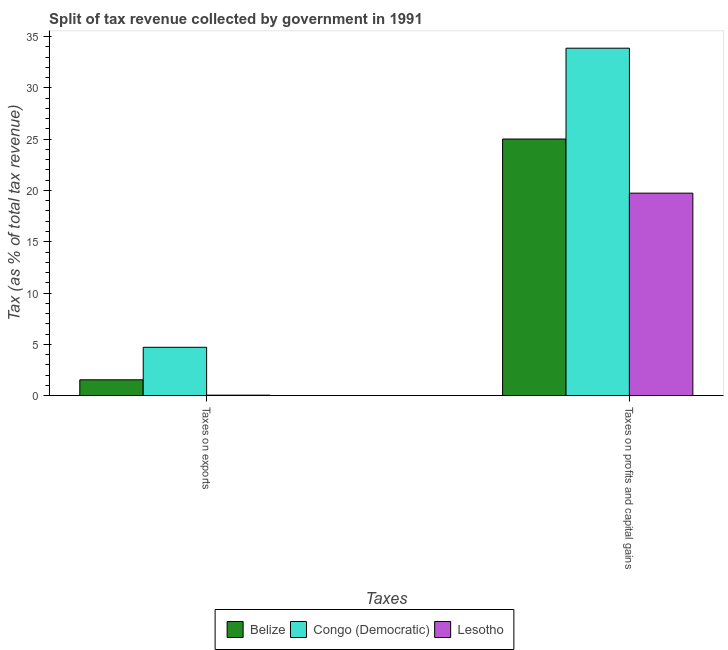How many different coloured bars are there?
Ensure brevity in your answer.  3. How many bars are there on the 1st tick from the left?
Your response must be concise. 3. What is the label of the 2nd group of bars from the left?
Your response must be concise. Taxes on profits and capital gains. What is the percentage of revenue obtained from taxes on profits and capital gains in Congo (Democratic)?
Provide a short and direct response. 33.86. Across all countries, what is the maximum percentage of revenue obtained from taxes on profits and capital gains?
Ensure brevity in your answer.  33.86. Across all countries, what is the minimum percentage of revenue obtained from taxes on profits and capital gains?
Your answer should be very brief. 19.74. In which country was the percentage of revenue obtained from taxes on profits and capital gains maximum?
Offer a terse response. Congo (Democratic). In which country was the percentage of revenue obtained from taxes on profits and capital gains minimum?
Make the answer very short. Lesotho. What is the total percentage of revenue obtained from taxes on profits and capital gains in the graph?
Your answer should be compact. 78.61. What is the difference between the percentage of revenue obtained from taxes on profits and capital gains in Belize and that in Lesotho?
Make the answer very short. 5.28. What is the difference between the percentage of revenue obtained from taxes on profits and capital gains in Lesotho and the percentage of revenue obtained from taxes on exports in Congo (Democratic)?
Ensure brevity in your answer.  15.02. What is the average percentage of revenue obtained from taxes on exports per country?
Keep it short and to the point. 2.1. What is the difference between the percentage of revenue obtained from taxes on profits and capital gains and percentage of revenue obtained from taxes on exports in Lesotho?
Provide a short and direct response. 19.69. In how many countries, is the percentage of revenue obtained from taxes on profits and capital gains greater than 21 %?
Give a very brief answer. 2. What is the ratio of the percentage of revenue obtained from taxes on profits and capital gains in Congo (Democratic) to that in Lesotho?
Provide a succinct answer. 1.72. Is the percentage of revenue obtained from taxes on profits and capital gains in Congo (Democratic) less than that in Belize?
Offer a terse response. No. In how many countries, is the percentage of revenue obtained from taxes on profits and capital gains greater than the average percentage of revenue obtained from taxes on profits and capital gains taken over all countries?
Your response must be concise. 1. What does the 2nd bar from the left in Taxes on exports represents?
Provide a succinct answer. Congo (Democratic). What does the 2nd bar from the right in Taxes on profits and capital gains represents?
Offer a terse response. Congo (Democratic). Are all the bars in the graph horizontal?
Your answer should be compact. No. How many countries are there in the graph?
Provide a succinct answer. 3. What is the difference between two consecutive major ticks on the Y-axis?
Offer a very short reply. 5. What is the title of the graph?
Give a very brief answer. Split of tax revenue collected by government in 1991. Does "St. Kitts and Nevis" appear as one of the legend labels in the graph?
Keep it short and to the point. No. What is the label or title of the X-axis?
Provide a succinct answer. Taxes. What is the label or title of the Y-axis?
Your answer should be compact. Tax (as % of total tax revenue). What is the Tax (as % of total tax revenue) in Belize in Taxes on exports?
Give a very brief answer. 1.54. What is the Tax (as % of total tax revenue) of Congo (Democratic) in Taxes on exports?
Give a very brief answer. 4.71. What is the Tax (as % of total tax revenue) in Lesotho in Taxes on exports?
Provide a succinct answer. 0.05. What is the Tax (as % of total tax revenue) in Belize in Taxes on profits and capital gains?
Make the answer very short. 25.01. What is the Tax (as % of total tax revenue) in Congo (Democratic) in Taxes on profits and capital gains?
Make the answer very short. 33.86. What is the Tax (as % of total tax revenue) in Lesotho in Taxes on profits and capital gains?
Offer a very short reply. 19.74. Across all Taxes, what is the maximum Tax (as % of total tax revenue) in Belize?
Offer a terse response. 25.01. Across all Taxes, what is the maximum Tax (as % of total tax revenue) in Congo (Democratic)?
Offer a terse response. 33.86. Across all Taxes, what is the maximum Tax (as % of total tax revenue) of Lesotho?
Your answer should be very brief. 19.74. Across all Taxes, what is the minimum Tax (as % of total tax revenue) of Belize?
Keep it short and to the point. 1.54. Across all Taxes, what is the minimum Tax (as % of total tax revenue) in Congo (Democratic)?
Offer a terse response. 4.71. Across all Taxes, what is the minimum Tax (as % of total tax revenue) in Lesotho?
Your response must be concise. 0.05. What is the total Tax (as % of total tax revenue) of Belize in the graph?
Give a very brief answer. 26.56. What is the total Tax (as % of total tax revenue) in Congo (Democratic) in the graph?
Your response must be concise. 38.58. What is the total Tax (as % of total tax revenue) in Lesotho in the graph?
Make the answer very short. 19.78. What is the difference between the Tax (as % of total tax revenue) of Belize in Taxes on exports and that in Taxes on profits and capital gains?
Make the answer very short. -23.47. What is the difference between the Tax (as % of total tax revenue) in Congo (Democratic) in Taxes on exports and that in Taxes on profits and capital gains?
Provide a succinct answer. -29.15. What is the difference between the Tax (as % of total tax revenue) of Lesotho in Taxes on exports and that in Taxes on profits and capital gains?
Ensure brevity in your answer.  -19.69. What is the difference between the Tax (as % of total tax revenue) of Belize in Taxes on exports and the Tax (as % of total tax revenue) of Congo (Democratic) in Taxes on profits and capital gains?
Offer a terse response. -32.32. What is the difference between the Tax (as % of total tax revenue) in Belize in Taxes on exports and the Tax (as % of total tax revenue) in Lesotho in Taxes on profits and capital gains?
Your answer should be very brief. -18.19. What is the difference between the Tax (as % of total tax revenue) of Congo (Democratic) in Taxes on exports and the Tax (as % of total tax revenue) of Lesotho in Taxes on profits and capital gains?
Offer a very short reply. -15.02. What is the average Tax (as % of total tax revenue) in Belize per Taxes?
Keep it short and to the point. 13.28. What is the average Tax (as % of total tax revenue) of Congo (Democratic) per Taxes?
Offer a terse response. 19.29. What is the average Tax (as % of total tax revenue) of Lesotho per Taxes?
Provide a short and direct response. 9.89. What is the difference between the Tax (as % of total tax revenue) in Belize and Tax (as % of total tax revenue) in Congo (Democratic) in Taxes on exports?
Provide a short and direct response. -3.17. What is the difference between the Tax (as % of total tax revenue) in Belize and Tax (as % of total tax revenue) in Lesotho in Taxes on exports?
Keep it short and to the point. 1.5. What is the difference between the Tax (as % of total tax revenue) of Congo (Democratic) and Tax (as % of total tax revenue) of Lesotho in Taxes on exports?
Keep it short and to the point. 4.67. What is the difference between the Tax (as % of total tax revenue) of Belize and Tax (as % of total tax revenue) of Congo (Democratic) in Taxes on profits and capital gains?
Offer a very short reply. -8.85. What is the difference between the Tax (as % of total tax revenue) in Belize and Tax (as % of total tax revenue) in Lesotho in Taxes on profits and capital gains?
Provide a succinct answer. 5.28. What is the difference between the Tax (as % of total tax revenue) in Congo (Democratic) and Tax (as % of total tax revenue) in Lesotho in Taxes on profits and capital gains?
Provide a short and direct response. 14.13. What is the ratio of the Tax (as % of total tax revenue) in Belize in Taxes on exports to that in Taxes on profits and capital gains?
Give a very brief answer. 0.06. What is the ratio of the Tax (as % of total tax revenue) of Congo (Democratic) in Taxes on exports to that in Taxes on profits and capital gains?
Offer a very short reply. 0.14. What is the ratio of the Tax (as % of total tax revenue) of Lesotho in Taxes on exports to that in Taxes on profits and capital gains?
Offer a very short reply. 0. What is the difference between the highest and the second highest Tax (as % of total tax revenue) in Belize?
Your answer should be very brief. 23.47. What is the difference between the highest and the second highest Tax (as % of total tax revenue) of Congo (Democratic)?
Provide a succinct answer. 29.15. What is the difference between the highest and the second highest Tax (as % of total tax revenue) of Lesotho?
Make the answer very short. 19.69. What is the difference between the highest and the lowest Tax (as % of total tax revenue) in Belize?
Your answer should be very brief. 23.47. What is the difference between the highest and the lowest Tax (as % of total tax revenue) of Congo (Democratic)?
Your answer should be compact. 29.15. What is the difference between the highest and the lowest Tax (as % of total tax revenue) in Lesotho?
Your answer should be compact. 19.69. 